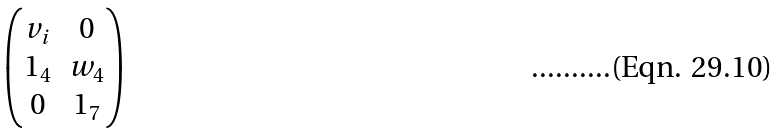Convert formula to latex. <formula><loc_0><loc_0><loc_500><loc_500>\begin{pmatrix} v _ { i } & 0 \\ 1 _ { 4 } & w _ { 4 } \\ 0 & 1 _ { 7 } \end{pmatrix}</formula> 